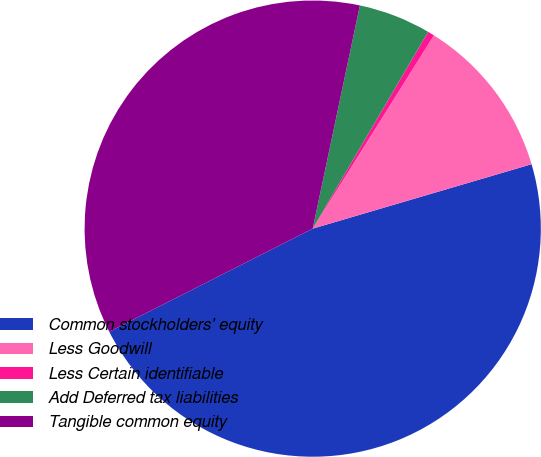<chart> <loc_0><loc_0><loc_500><loc_500><pie_chart><fcel>Common stockholders' equity<fcel>Less Goodwill<fcel>Less Certain identifiable<fcel>Add Deferred tax liabilities<fcel>Tangible common equity<nl><fcel>47.09%<fcel>11.53%<fcel>0.47%<fcel>5.13%<fcel>35.78%<nl></chart> 